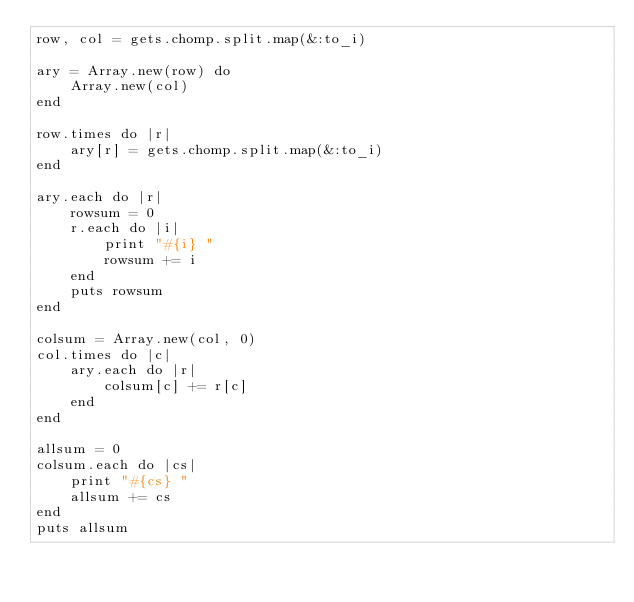<code> <loc_0><loc_0><loc_500><loc_500><_Ruby_>row, col = gets.chomp.split.map(&:to_i)

ary = Array.new(row) do
    Array.new(col)
end

row.times do |r|
    ary[r] = gets.chomp.split.map(&:to_i)
end

ary.each do |r|
    rowsum = 0
    r.each do |i|
        print "#{i} "
        rowsum += i
    end
    puts rowsum
end

colsum = Array.new(col, 0)
col.times do |c|
    ary.each do |r|
        colsum[c] += r[c]
    end
end

allsum = 0
colsum.each do |cs|
    print "#{cs} "
    allsum += cs
end
puts allsum</code> 